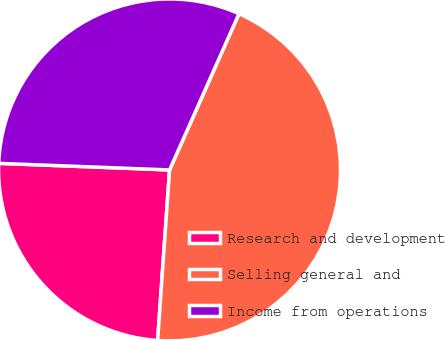Convert chart. <chart><loc_0><loc_0><loc_500><loc_500><pie_chart><fcel>Research and development<fcel>Selling general and<fcel>Income from operations<nl><fcel>24.5%<fcel>44.46%<fcel>31.04%<nl></chart> 